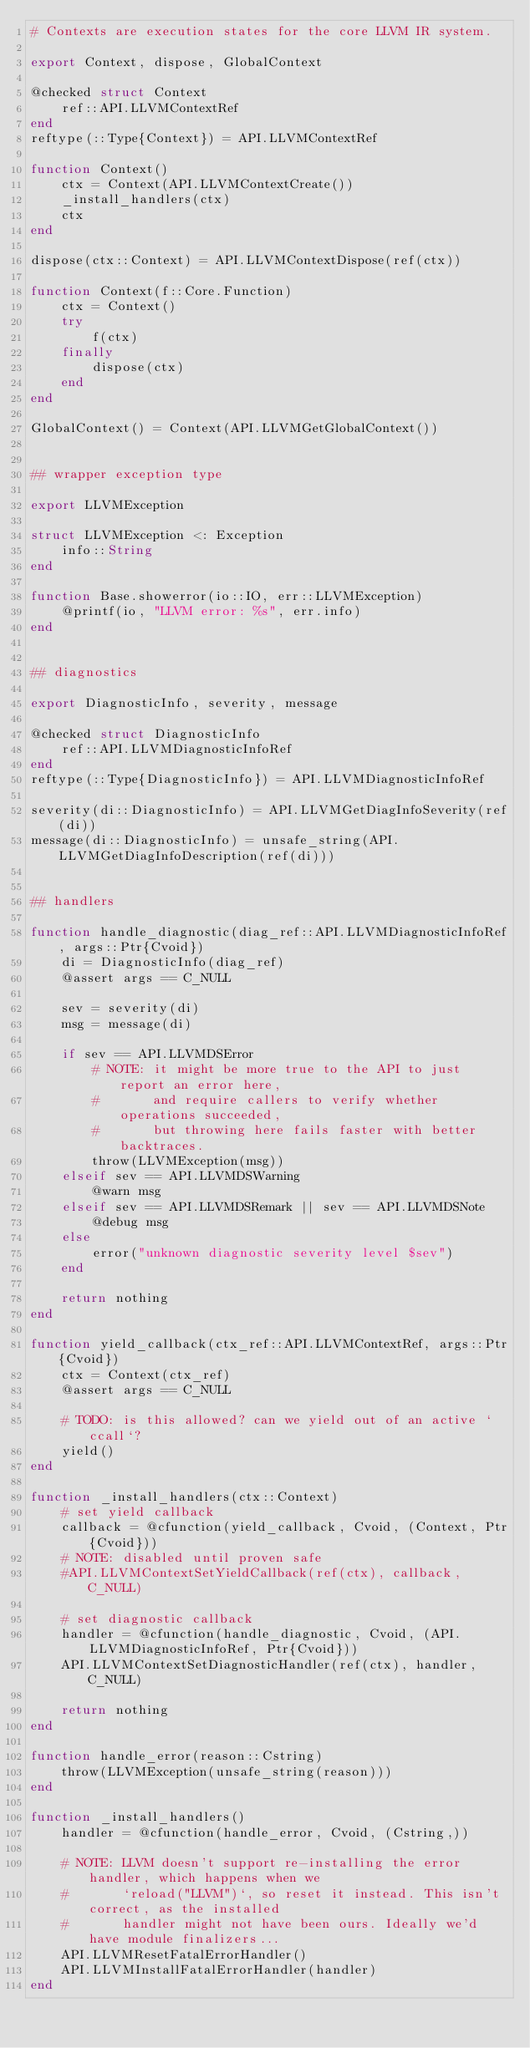<code> <loc_0><loc_0><loc_500><loc_500><_Julia_># Contexts are execution states for the core LLVM IR system.

export Context, dispose, GlobalContext

@checked struct Context
    ref::API.LLVMContextRef
end
reftype(::Type{Context}) = API.LLVMContextRef

function Context()
    ctx = Context(API.LLVMContextCreate())
    _install_handlers(ctx)
    ctx
end

dispose(ctx::Context) = API.LLVMContextDispose(ref(ctx))

function Context(f::Core.Function)
    ctx = Context()
    try
        f(ctx)
    finally
        dispose(ctx)
    end
end

GlobalContext() = Context(API.LLVMGetGlobalContext())


## wrapper exception type

export LLVMException

struct LLVMException <: Exception
    info::String
end

function Base.showerror(io::IO, err::LLVMException)
    @printf(io, "LLVM error: %s", err.info)
end


## diagnostics

export DiagnosticInfo, severity, message

@checked struct DiagnosticInfo
    ref::API.LLVMDiagnosticInfoRef
end
reftype(::Type{DiagnosticInfo}) = API.LLVMDiagnosticInfoRef

severity(di::DiagnosticInfo) = API.LLVMGetDiagInfoSeverity(ref(di))
message(di::DiagnosticInfo) = unsafe_string(API.LLVMGetDiagInfoDescription(ref(di)))


## handlers

function handle_diagnostic(diag_ref::API.LLVMDiagnosticInfoRef, args::Ptr{Cvoid})
    di = DiagnosticInfo(diag_ref)
    @assert args == C_NULL

    sev = severity(di)
    msg = message(di)

    if sev == API.LLVMDSError
        # NOTE: it might be more true to the API to just report an error here,
        #       and require callers to verify whether operations succeeded,
        #       but throwing here fails faster with better backtraces.
        throw(LLVMException(msg))
    elseif sev == API.LLVMDSWarning
        @warn msg
    elseif sev == API.LLVMDSRemark || sev == API.LLVMDSNote
        @debug msg
    else
        error("unknown diagnostic severity level $sev")
    end

    return nothing
end

function yield_callback(ctx_ref::API.LLVMContextRef, args::Ptr{Cvoid})
    ctx = Context(ctx_ref)
    @assert args == C_NULL

    # TODO: is this allowed? can we yield out of an active `ccall`?
    yield()
end

function _install_handlers(ctx::Context)
    # set yield callback
    callback = @cfunction(yield_callback, Cvoid, (Context, Ptr{Cvoid}))
    # NOTE: disabled until proven safe
    #API.LLVMContextSetYieldCallback(ref(ctx), callback, C_NULL)

    # set diagnostic callback
    handler = @cfunction(handle_diagnostic, Cvoid, (API.LLVMDiagnosticInfoRef, Ptr{Cvoid}))
    API.LLVMContextSetDiagnosticHandler(ref(ctx), handler, C_NULL)

    return nothing
end

function handle_error(reason::Cstring)
    throw(LLVMException(unsafe_string(reason)))
end

function _install_handlers()
    handler = @cfunction(handle_error, Cvoid, (Cstring,))

    # NOTE: LLVM doesn't support re-installing the error handler, which happens when we
    #       `reload("LLVM")`, so reset it instead. This isn't correct, as the installed
    #       handler might not have been ours. Ideally we'd have module finalizers...
    API.LLVMResetFatalErrorHandler()
    API.LLVMInstallFatalErrorHandler(handler)
end
</code> 